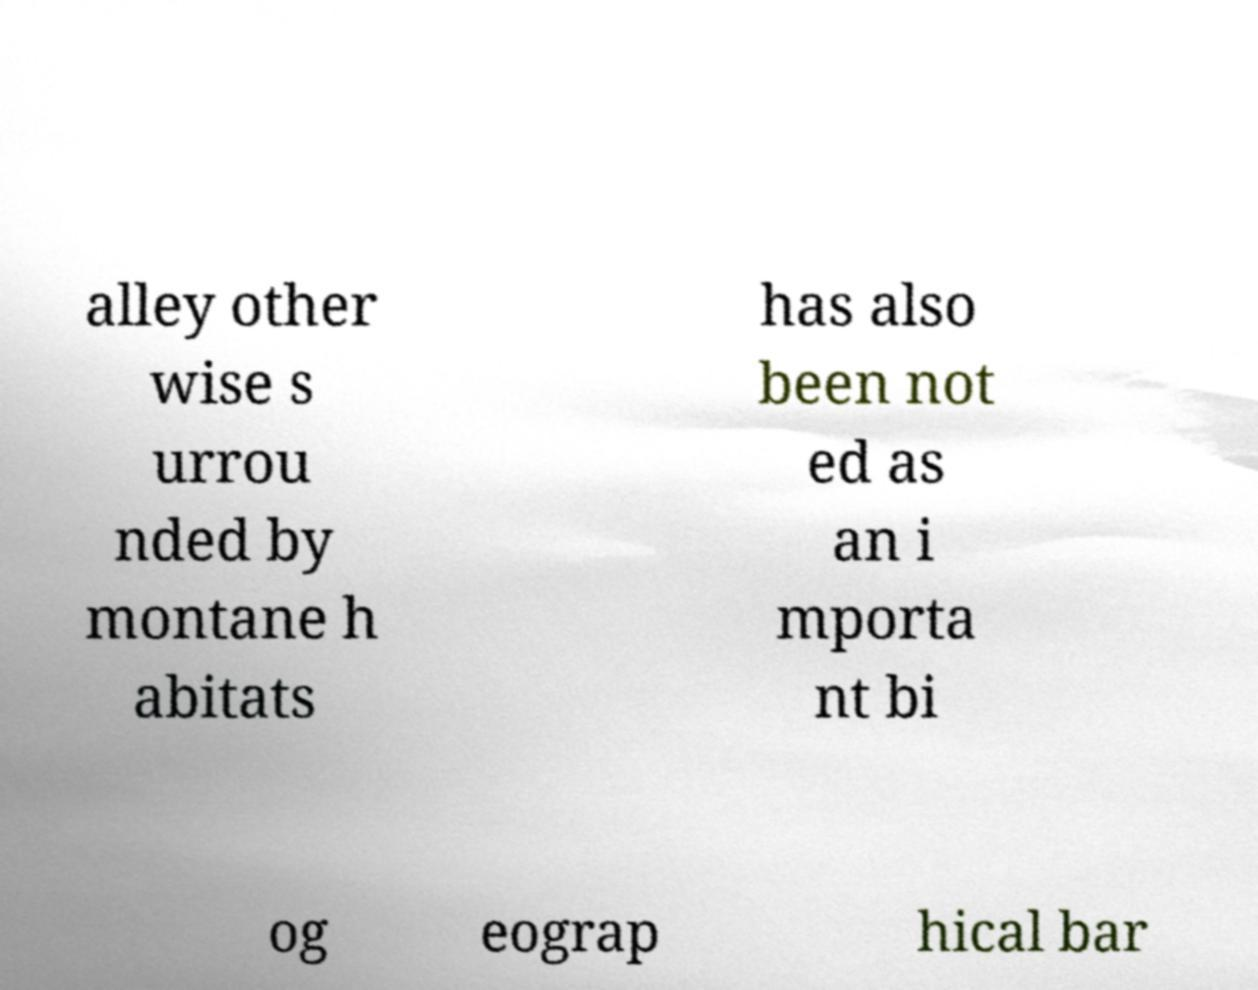What messages or text are displayed in this image? I need them in a readable, typed format. alley other wise s urrou nded by montane h abitats has also been not ed as an i mporta nt bi og eograp hical bar 